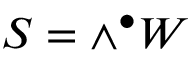Convert formula to latex. <formula><loc_0><loc_0><loc_500><loc_500>S = \wedge ^ { \bullet } W</formula> 